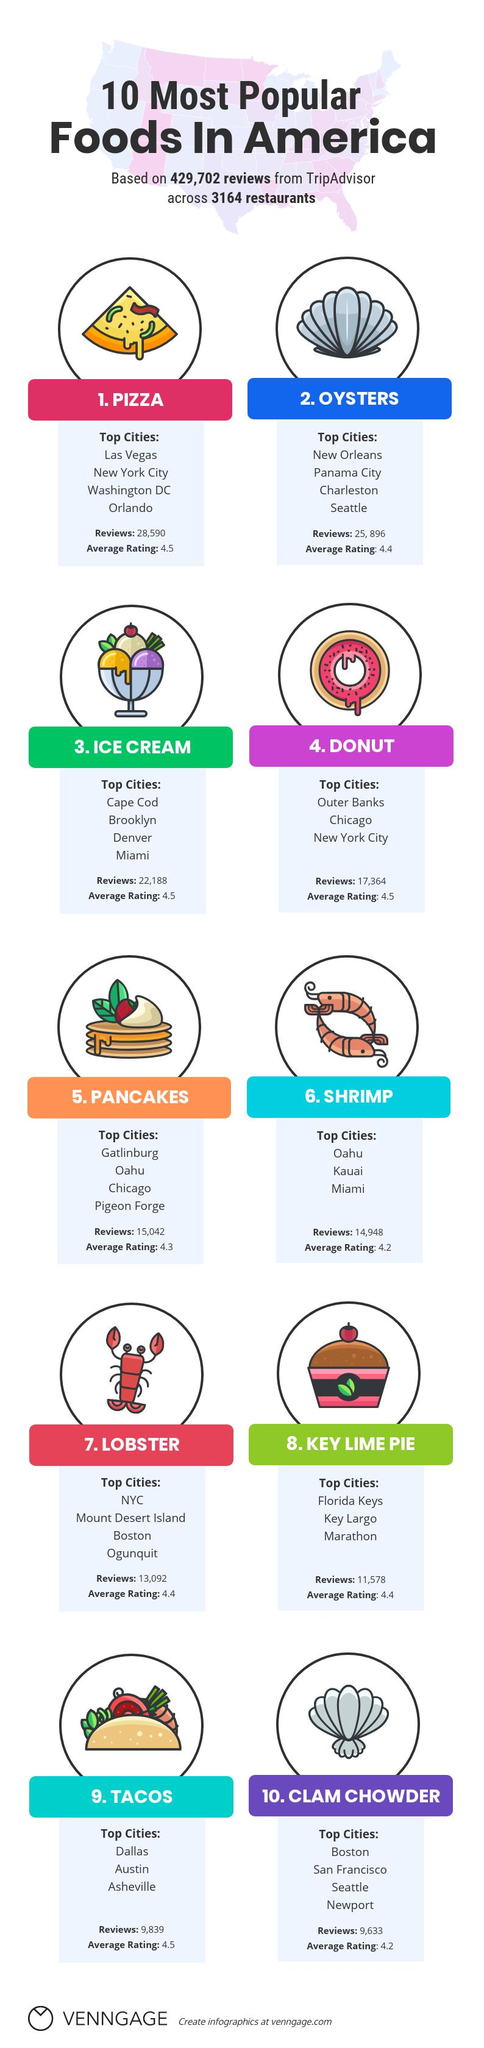Specify some key components in this picture. It is not clear which foods have the same rating as Tacos, Pancakes, Pizza, and Donuts. Miami enjoys consuming shrimps and ice creams. Seattle is renowned for its delectable cuisine, particularly its seafood delights. Oysters and Clam Chowder are two of the most popular dishes in this coastal city. These food items have an average rating of 4.4 out of 5.0. Pizza has a higher number of food reviews compared to ice cream and donuts. 